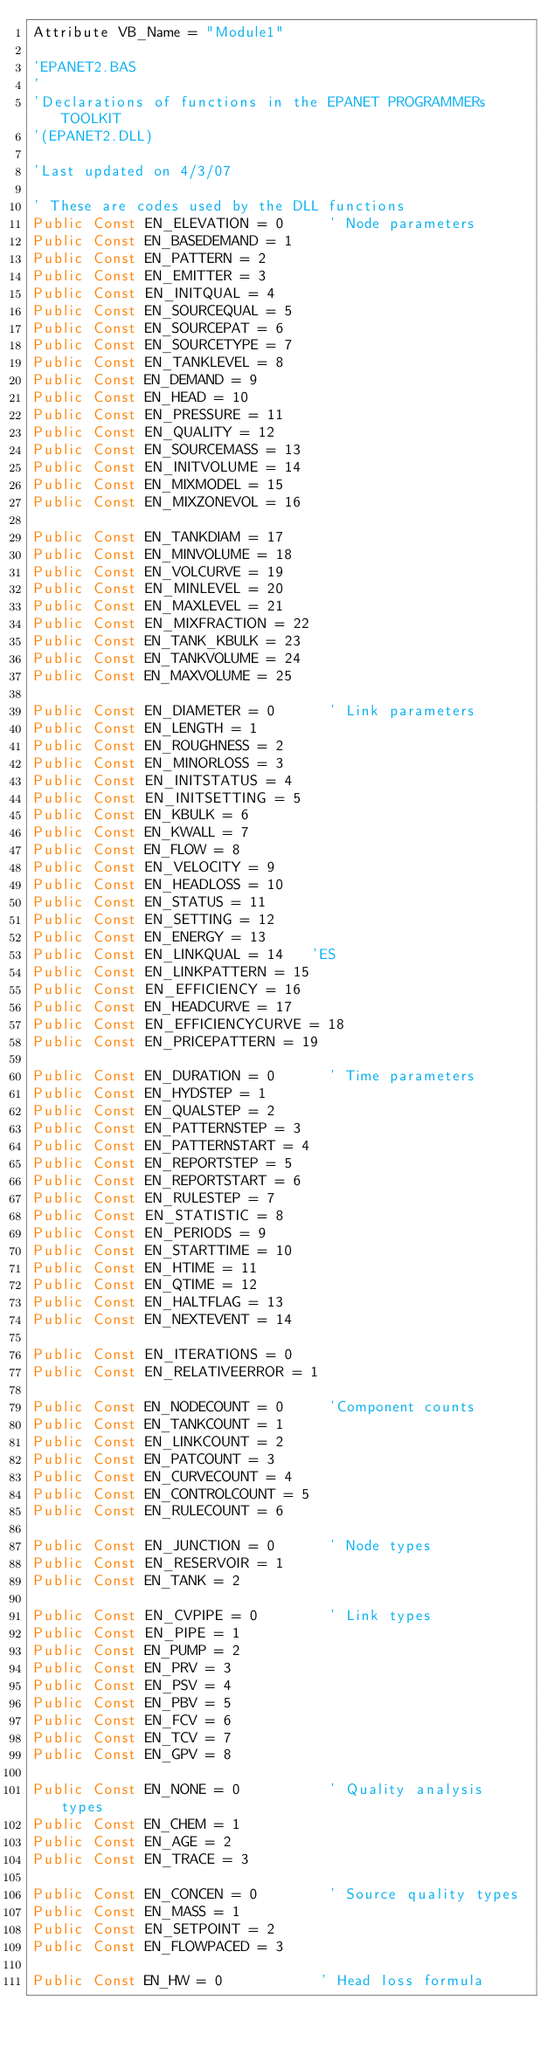Convert code to text. <code><loc_0><loc_0><loc_500><loc_500><_VisualBasic_>Attribute VB_Name = "Module1"

'EPANET2.BAS
'
'Declarations of functions in the EPANET PROGRAMMERs TOOLKIT
'(EPANET2.DLL)

'Last updated on 4/3/07

' These are codes used by the DLL functions
Public Const EN_ELEVATION = 0     ' Node parameters
Public Const EN_BASEDEMAND = 1
Public Const EN_PATTERN = 2
Public Const EN_EMITTER = 3
Public Const EN_INITQUAL = 4
Public Const EN_SOURCEQUAL = 5
Public Const EN_SOURCEPAT = 6
Public Const EN_SOURCETYPE = 7
Public Const EN_TANKLEVEL = 8
Public Const EN_DEMAND = 9
Public Const EN_HEAD = 10
Public Const EN_PRESSURE = 11
Public Const EN_QUALITY = 12
Public Const EN_SOURCEMASS = 13
Public Const EN_INITVOLUME = 14
Public Const EN_MIXMODEL = 15
Public Const EN_MIXZONEVOL = 16

Public Const EN_TANKDIAM = 17
Public Const EN_MINVOLUME = 18
Public Const EN_VOLCURVE = 19
Public Const EN_MINLEVEL = 20
Public Const EN_MAXLEVEL = 21
Public Const EN_MIXFRACTION = 22
Public Const EN_TANK_KBULK = 23
Public Const EN_TANKVOLUME = 24
Public Const EN_MAXVOLUME = 25

Public Const EN_DIAMETER = 0      ' Link parameters
Public Const EN_LENGTH = 1
Public Const EN_ROUGHNESS = 2
Public Const EN_MINORLOSS = 3
Public Const EN_INITSTATUS = 4
Public Const EN_INITSETTING = 5
Public Const EN_KBULK = 6
Public Const EN_KWALL = 7
Public Const EN_FLOW = 8
Public Const EN_VELOCITY = 9
Public Const EN_HEADLOSS = 10
Public Const EN_STATUS = 11
Public Const EN_SETTING = 12
Public Const EN_ENERGY = 13
Public Const EN_LINKQUAL = 14   'ES
Public Const EN_LINKPATTERN = 15
Public Const EN_EFFICIENCY = 16
Public Const EN_HEADCURVE = 17
Public Const EN_EFFICIENCYCURVE = 18
Public Const EN_PRICEPATTERN = 19

Public Const EN_DURATION = 0      ' Time parameters
Public Const EN_HYDSTEP = 1
Public Const EN_QUALSTEP = 2
Public Const EN_PATTERNSTEP = 3
Public Const EN_PATTERNSTART = 4
Public Const EN_REPORTSTEP = 5
Public Const EN_REPORTSTART = 6
Public Const EN_RULESTEP = 7
Public Const EN_STATISTIC = 8
Public Const EN_PERIODS = 9
Public Const EN_STARTTIME = 10
Public Const EN_HTIME = 11
Public Const EN_QTIME = 12
Public Const EN_HALTFLAG = 13
Public Const EN_NEXTEVENT = 14

Public Const EN_ITERATIONS = 0
Public Const EN_RELATIVEERROR = 1

Public Const EN_NODECOUNT = 0     'Component counts
Public Const EN_TANKCOUNT = 1
Public Const EN_LINKCOUNT = 2
Public Const EN_PATCOUNT = 3
Public Const EN_CURVECOUNT = 4
Public Const EN_CONTROLCOUNT = 5
Public Const EN_RULECOUNT = 6

Public Const EN_JUNCTION = 0      ' Node types
Public Const EN_RESERVOIR = 1
Public Const EN_TANK = 2

Public Const EN_CVPIPE = 0        ' Link types
Public Const EN_PIPE = 1
Public Const EN_PUMP = 2
Public Const EN_PRV = 3
Public Const EN_PSV = 4
Public Const EN_PBV = 5
Public Const EN_FCV = 6
Public Const EN_TCV = 7
Public Const EN_GPV = 8

Public Const EN_NONE = 0          ' Quality analysis types
Public Const EN_CHEM = 1
Public Const EN_AGE = 2
Public Const EN_TRACE = 3

Public Const EN_CONCEN = 0        ' Source quality types
Public Const EN_MASS = 1
Public Const EN_SETPOINT = 2
Public Const EN_FLOWPACED = 3

Public Const EN_HW = 0           ' Head loss formula</code> 